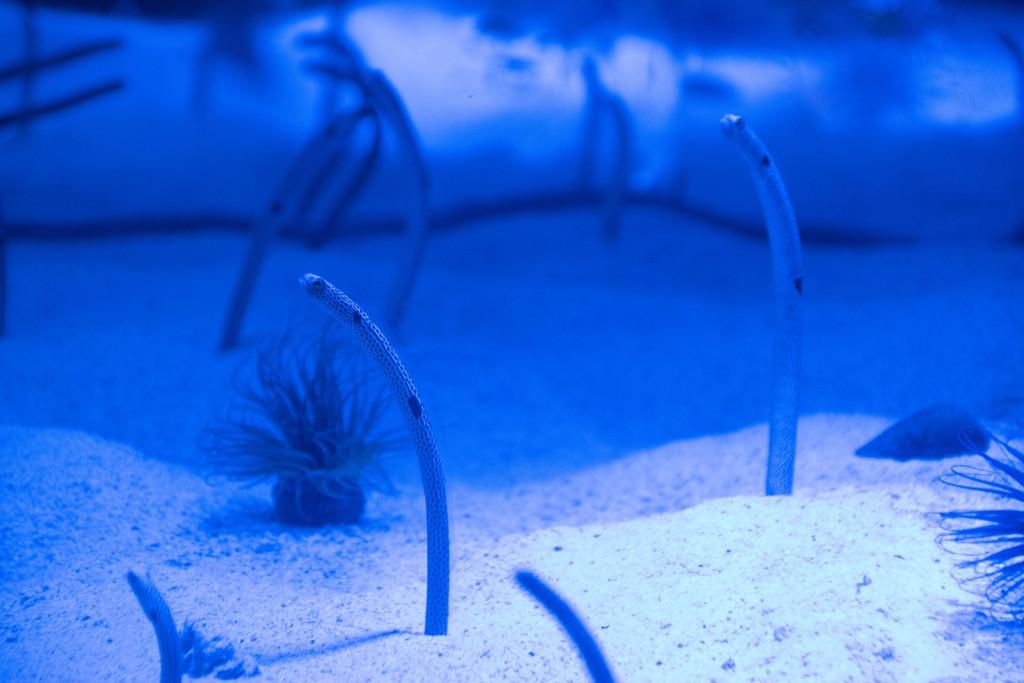How would you summarize this image in a sentence or two? This image is taken under the water. There are snakes. There is sand. 